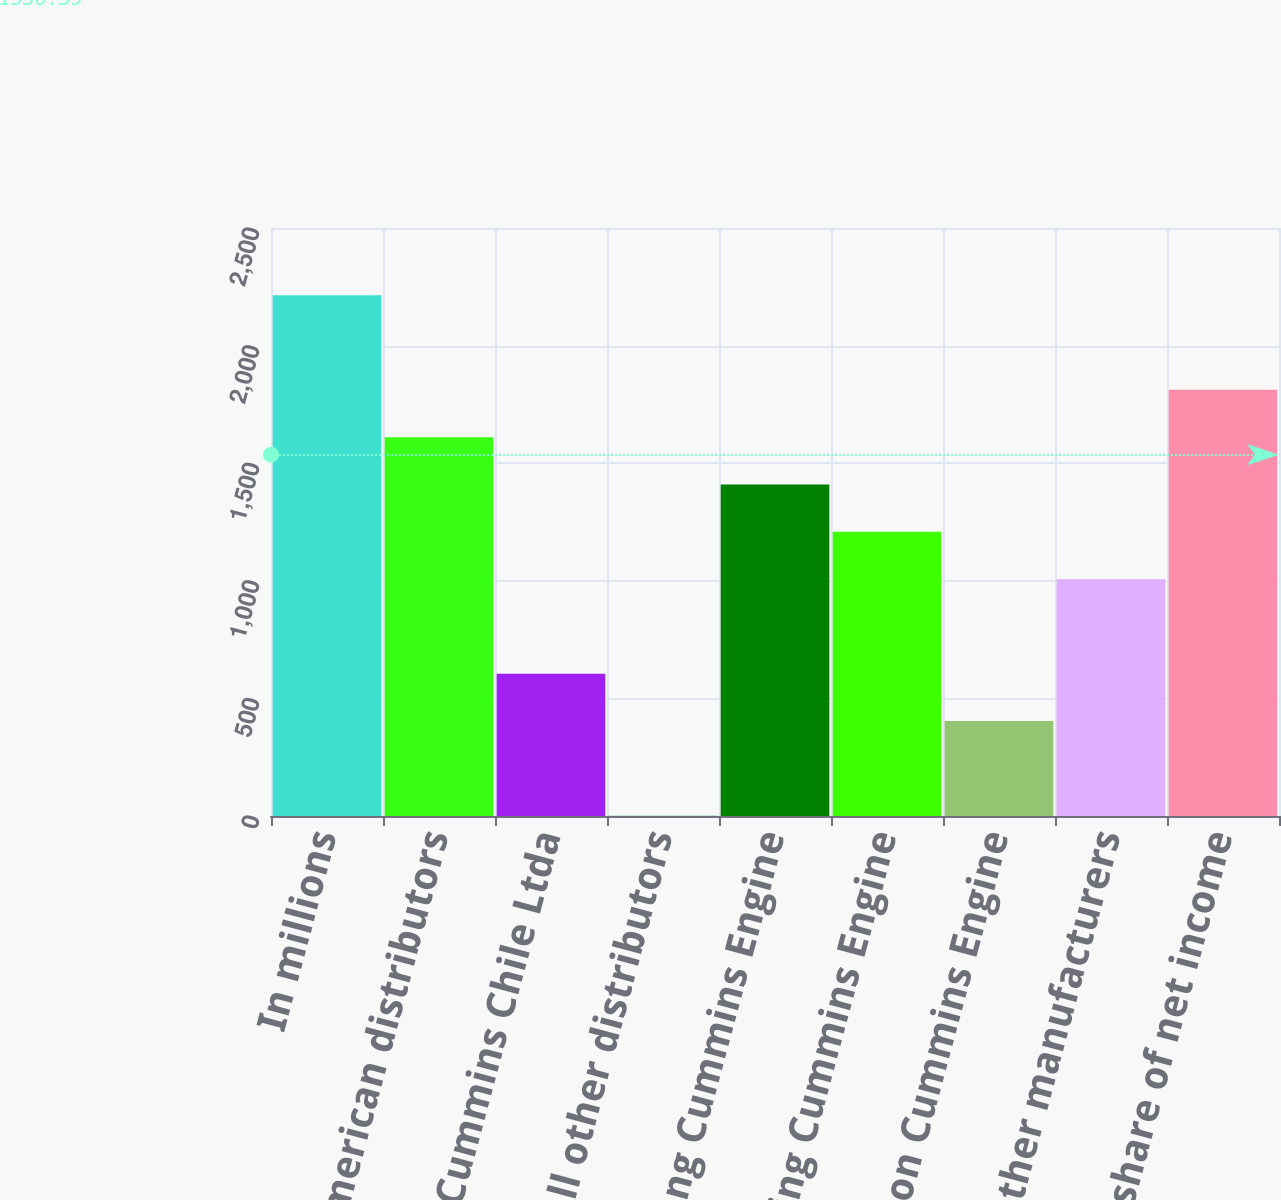Convert chart. <chart><loc_0><loc_0><loc_500><loc_500><bar_chart><fcel>In millions<fcel>North American distributors<fcel>Komatsu Cummins Chile Ltda<fcel>All other distributors<fcel>Dongfeng Cummins Engine<fcel>Chongqing Cummins Engine<fcel>Beijing Foton Cummins Engine<fcel>All other manufacturers<fcel>Cummins share of net income<nl><fcel>2214.2<fcel>1610.6<fcel>604.6<fcel>1<fcel>1409.4<fcel>1208.2<fcel>403.4<fcel>1007<fcel>1811.8<nl></chart> 